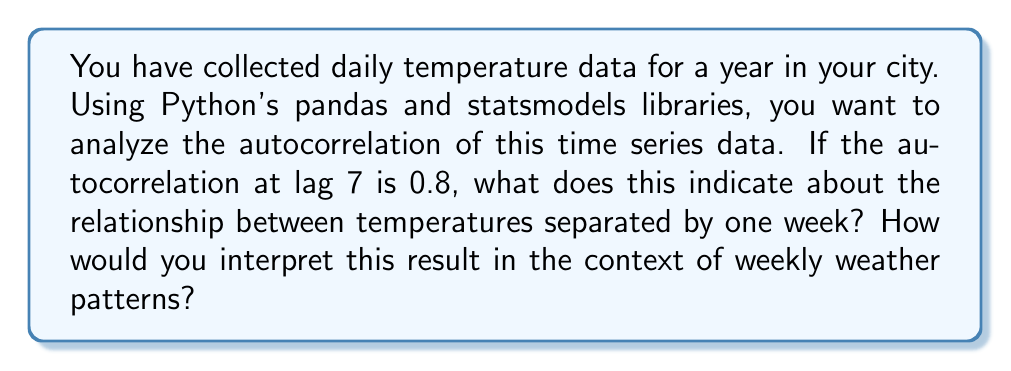Could you help me with this problem? To understand this question, let's break it down step-by-step:

1. Autocorrelation:
   Autocorrelation measures the correlation between a time series and a lagged version of itself. It's calculated as:

   $$ \rho_k = \frac{\sum_{t=k+1}^{n} (y_t - \bar{y})(y_{t-k} - \bar{y})}{\sum_{t=1}^{n} (y_t - \bar{y})^2} $$

   where $\rho_k$ is the autocorrelation at lag $k$, $y_t$ is the value at time $t$, and $\bar{y}$ is the mean of the series.

2. Interpreting autocorrelation:
   - Autocorrelation ranges from -1 to 1.
   - A value close to 1 indicates strong positive correlation.
   - A value close to -1 indicates strong negative correlation.
   - A value close to 0 indicates little to no correlation.

3. In this case:
   - Lag 7 corresponds to a 7-day (one week) difference.
   - The autocorrelation at lag 7 is 0.8.

4. Interpretation:
   - 0.8 is close to 1, indicating a strong positive correlation.
   - This means that temperatures separated by one week are strongly related.
   - If it's warmer than average today, it's likely to be warmer than average in 7 days.

5. Weekly weather patterns:
   - This high autocorrelation suggests a weekly cycle in temperature.
   - It could indicate that weather patterns tend to repeat on a weekly basis.
   - Factors like consistent wind patterns or regular weather systems might contribute to this weekly cycle.

To calculate this in Python, you would typically use:

```python
import pandas as pd
from statsmodels.tsa.stattools import acf

# Assuming 'temp_data' is your pandas Series of temperature data
autocorr = acf(temp_data, nlags=7)
print(f"Autocorrelation at lag 7: {autocorr[7]}")
```

This high autocorrelation at lag 7 suggests that there might be a weekly seasonality in your temperature data, which could be valuable for forecasting or understanding local climate patterns.
Answer: An autocorrelation of 0.8 at lag 7 indicates a strong positive relationship between temperatures separated by one week. This suggests that the temperature on a given day is likely to be similar to the temperature seven days before or after. In the context of weekly weather patterns, this high autocorrelation implies that there may be a consistent weekly cycle in temperature, possibly due to regular weather systems or other cyclical factors affecting your city's climate. 